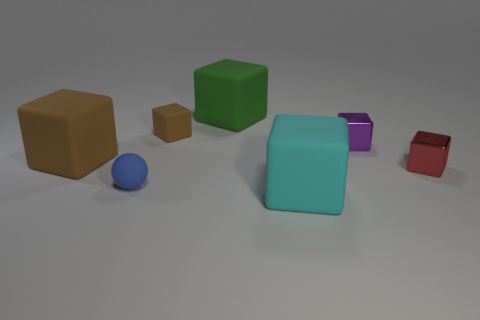Are there any other things of the same color as the tiny matte block?
Make the answer very short. Yes. Do the blue rubber object and the purple cube have the same size?
Your answer should be very brief. Yes. How many objects are large matte blocks in front of the tiny blue rubber sphere or big blocks that are in front of the big brown matte cube?
Offer a very short reply. 1. What is the material of the small block on the left side of the big block in front of the tiny red shiny object?
Offer a very short reply. Rubber. How many other objects are the same material as the small blue sphere?
Give a very brief answer. 4. Does the blue rubber thing have the same shape as the tiny red metal thing?
Provide a succinct answer. No. What size is the rubber cube in front of the small blue thing?
Offer a terse response. Large. Is the size of the purple block the same as the thing left of the blue sphere?
Your answer should be compact. No. Is the number of brown objects in front of the tiny purple object less than the number of tiny shiny cubes?
Your response must be concise. Yes. There is a tiny purple object that is the same shape as the tiny brown rubber object; what is it made of?
Provide a short and direct response. Metal. 